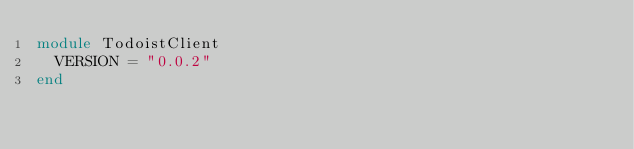Convert code to text. <code><loc_0><loc_0><loc_500><loc_500><_Ruby_>module TodoistClient
  VERSION = "0.0.2"
end
</code> 